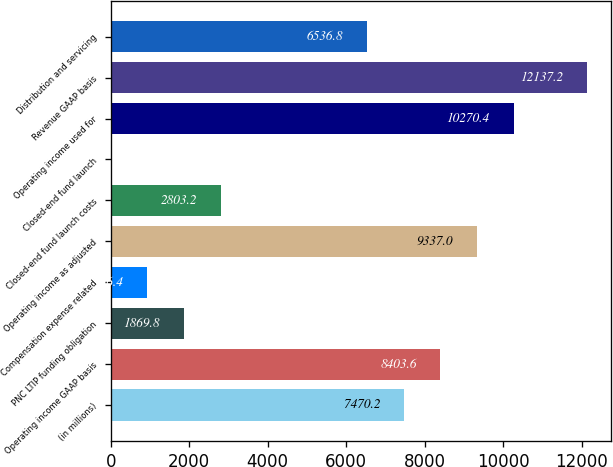Convert chart to OTSL. <chart><loc_0><loc_0><loc_500><loc_500><bar_chart><fcel>(in millions)<fcel>Operating income GAAP basis<fcel>PNC LTIP funding obligation<fcel>Compensation expense related<fcel>Operating income as adjusted<fcel>Closed-end fund launch costs<fcel>Closed-end fund launch<fcel>Operating income used for<fcel>Revenue GAAP basis<fcel>Distribution and servicing<nl><fcel>7470.2<fcel>8403.6<fcel>1869.8<fcel>936.4<fcel>9337<fcel>2803.2<fcel>3<fcel>10270.4<fcel>12137.2<fcel>6536.8<nl></chart> 